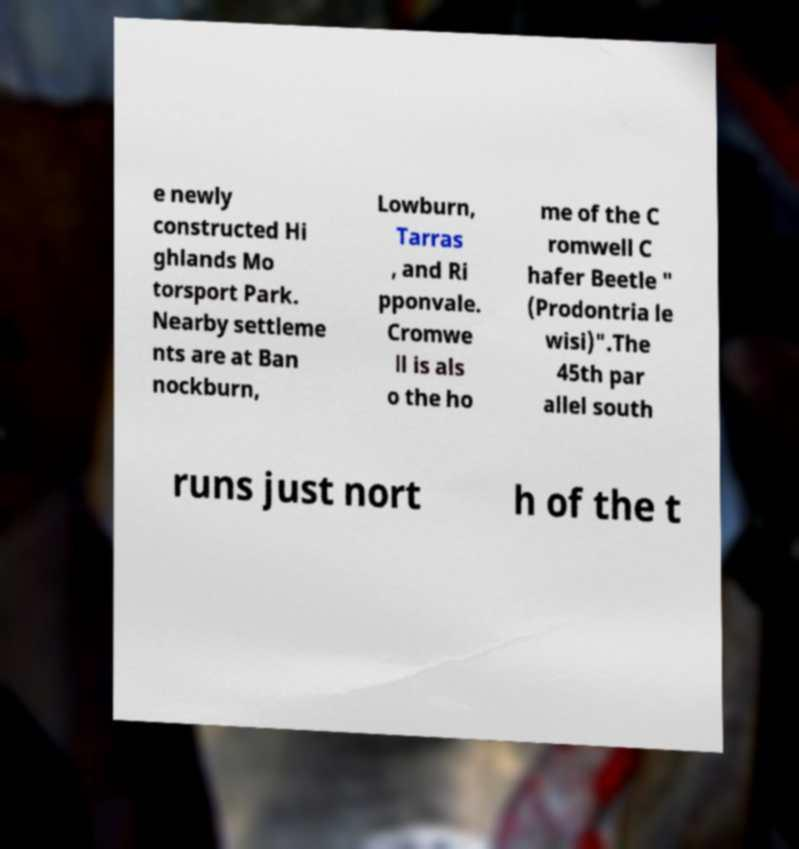Please read and relay the text visible in this image. What does it say? e newly constructed Hi ghlands Mo torsport Park. Nearby settleme nts are at Ban nockburn, Lowburn, Tarras , and Ri pponvale. Cromwe ll is als o the ho me of the C romwell C hafer Beetle " (Prodontria le wisi)".The 45th par allel south runs just nort h of the t 